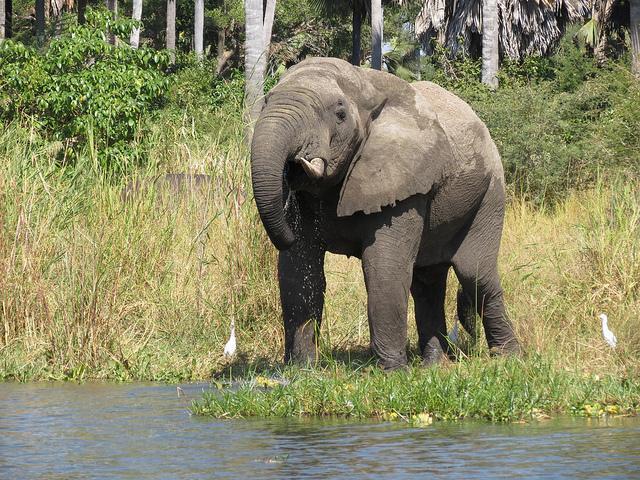How many birds are next to the right side of the elephant?
Give a very brief answer. 1. How many elephants are babies?
Give a very brief answer. 0. 